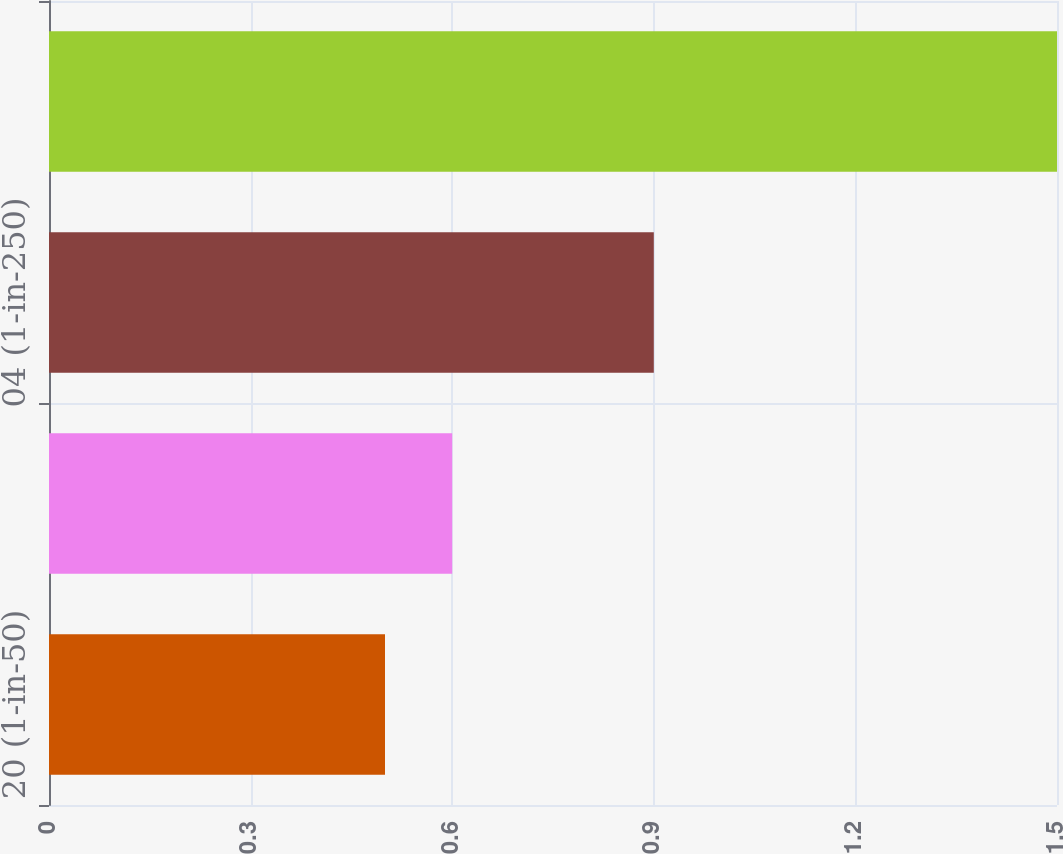<chart> <loc_0><loc_0><loc_500><loc_500><bar_chart><fcel>20 (1-in-50)<fcel>10 (1-in-100)<fcel>04 (1-in-250)<fcel>01 (1-in-1000)<nl><fcel>0.5<fcel>0.6<fcel>0.9<fcel>1.5<nl></chart> 